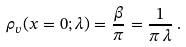<formula> <loc_0><loc_0><loc_500><loc_500>\rho _ { v } ( x = 0 ; \lambda ) = \frac { \beta } { \pi } = \frac { 1 } { \pi \, \lambda } \, .</formula> 